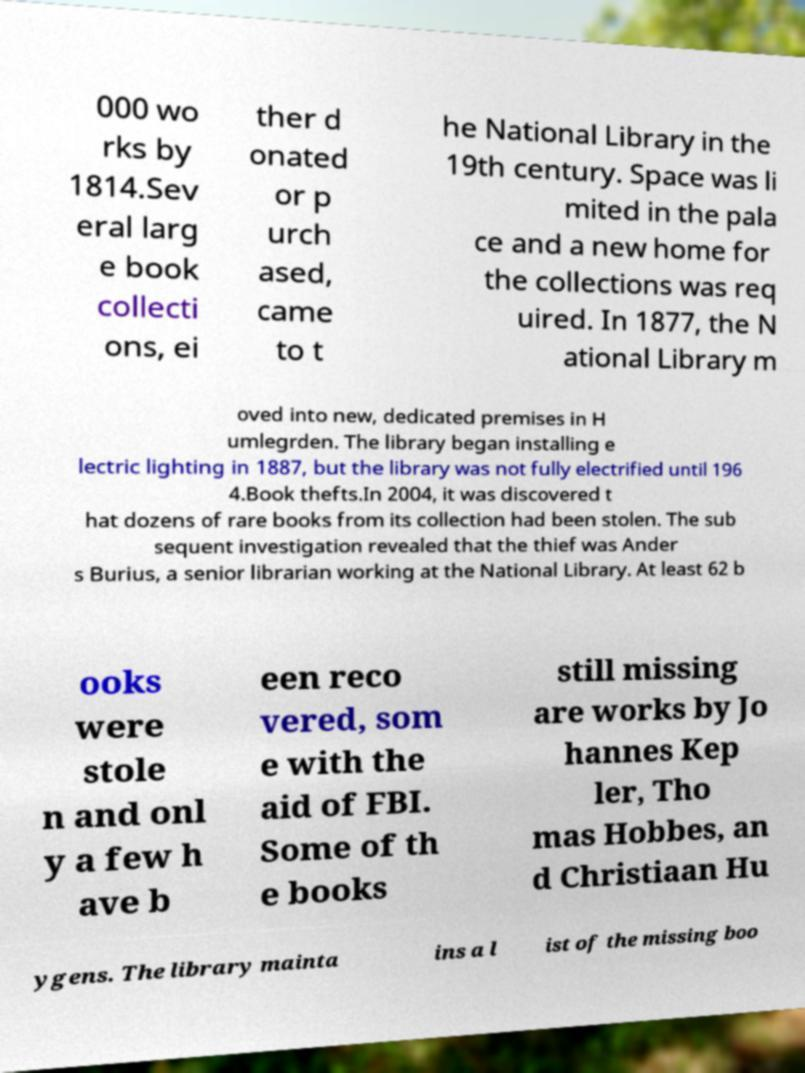For documentation purposes, I need the text within this image transcribed. Could you provide that? 000 wo rks by 1814.Sev eral larg e book collecti ons, ei ther d onated or p urch ased, came to t he National Library in the 19th century. Space was li mited in the pala ce and a new home for the collections was req uired. In 1877, the N ational Library m oved into new, dedicated premises in H umlegrden. The library began installing e lectric lighting in 1887, but the library was not fully electrified until 196 4.Book thefts.In 2004, it was discovered t hat dozens of rare books from its collection had been stolen. The sub sequent investigation revealed that the thief was Ander s Burius, a senior librarian working at the National Library. At least 62 b ooks were stole n and onl y a few h ave b een reco vered, som e with the aid of FBI. Some of th e books still missing are works by Jo hannes Kep ler, Tho mas Hobbes, an d Christiaan Hu ygens. The library mainta ins a l ist of the missing boo 